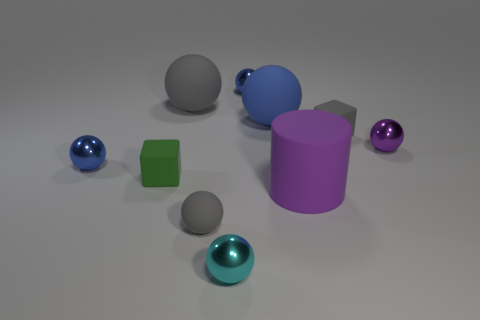Is the number of small cyan objects that are right of the gray cube greater than the number of gray rubber blocks?
Offer a very short reply. No. Is there a large purple rubber cylinder?
Your answer should be compact. Yes. How many things have the same size as the gray cube?
Offer a very short reply. 6. Is the number of gray rubber spheres right of the tiny purple object greater than the number of gray rubber balls right of the purple matte thing?
Provide a succinct answer. No. There is a purple object that is the same size as the cyan object; what is its material?
Your answer should be compact. Metal. What is the shape of the green object?
Keep it short and to the point. Cube. What number of purple things are either rubber spheres or large matte balls?
Keep it short and to the point. 0. There is a green object that is the same material as the big blue object; what is its size?
Your answer should be very brief. Small. Are the tiny block that is right of the large blue rubber ball and the gray sphere that is behind the gray block made of the same material?
Your answer should be compact. Yes. How many cubes are tiny red things or rubber objects?
Your response must be concise. 2. 